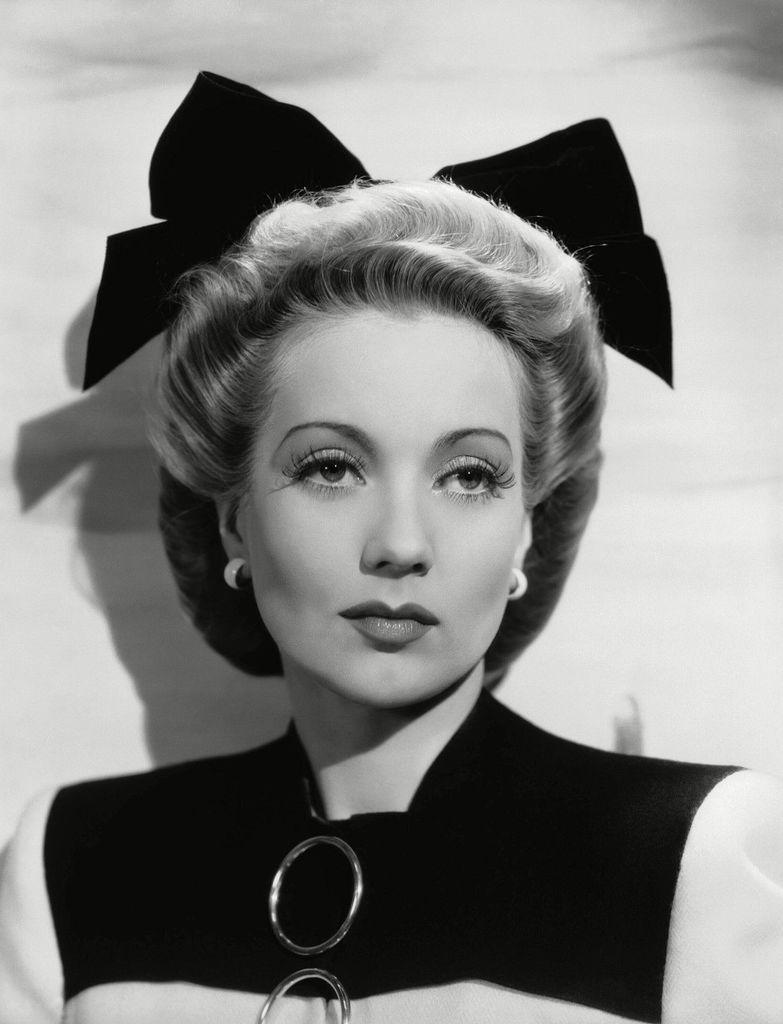Describe this image in one or two sentences. In this picture, we see a woman in black dress. I think she is posing for the photo. We see a black color ribbon on her head. In the background, it is white in color. This is a black and white picture. 